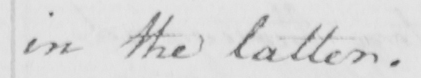Can you read and transcribe this handwriting? in the latter . 